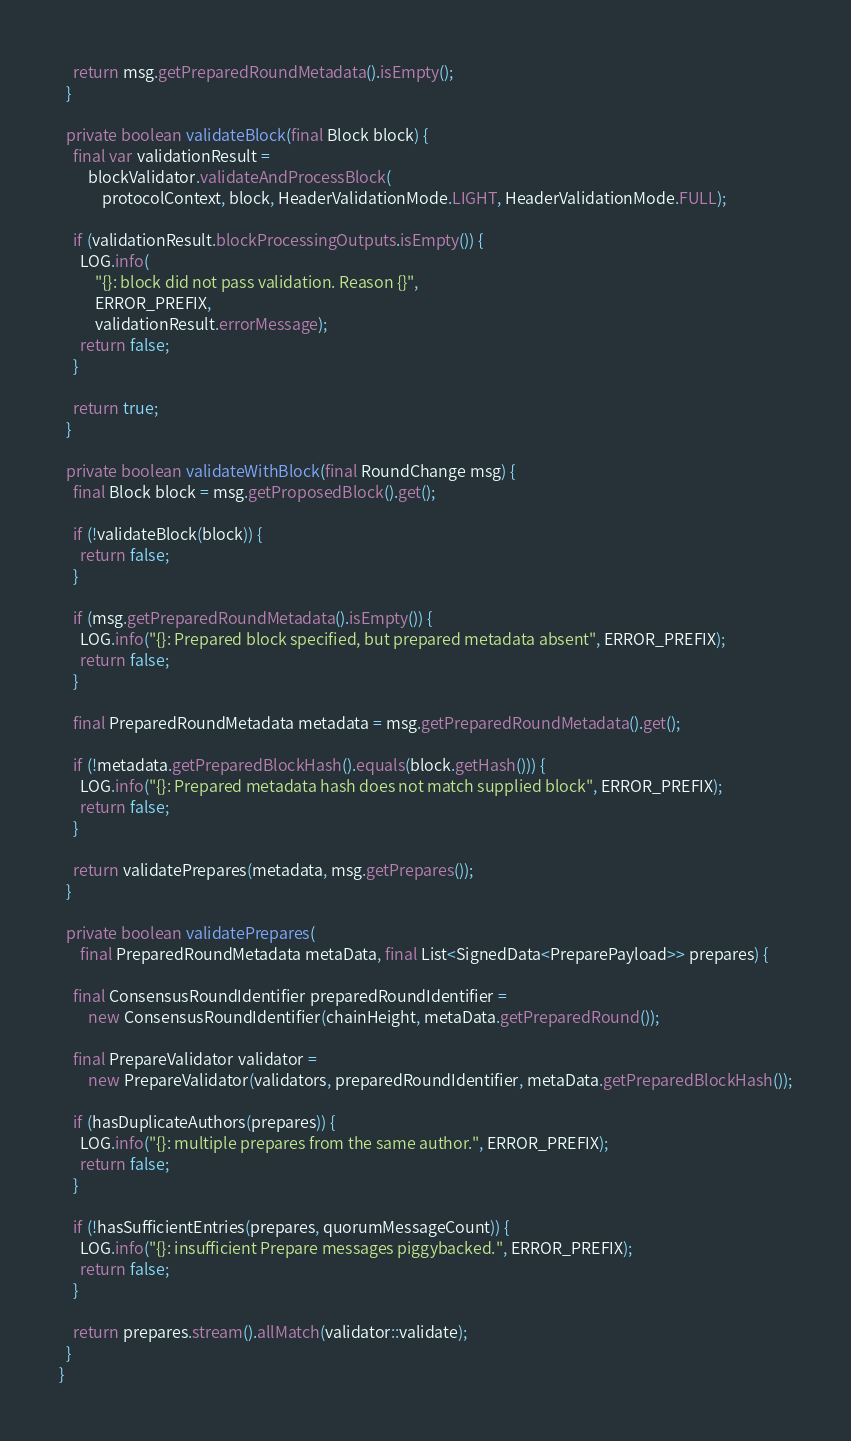Convert code to text. <code><loc_0><loc_0><loc_500><loc_500><_Java_>
    return msg.getPreparedRoundMetadata().isEmpty();
  }

  private boolean validateBlock(final Block block) {
    final var validationResult =
        blockValidator.validateAndProcessBlock(
            protocolContext, block, HeaderValidationMode.LIGHT, HeaderValidationMode.FULL);

    if (validationResult.blockProcessingOutputs.isEmpty()) {
      LOG.info(
          "{}: block did not pass validation. Reason {}",
          ERROR_PREFIX,
          validationResult.errorMessage);
      return false;
    }

    return true;
  }

  private boolean validateWithBlock(final RoundChange msg) {
    final Block block = msg.getProposedBlock().get();

    if (!validateBlock(block)) {
      return false;
    }

    if (msg.getPreparedRoundMetadata().isEmpty()) {
      LOG.info("{}: Prepared block specified, but prepared metadata absent", ERROR_PREFIX);
      return false;
    }

    final PreparedRoundMetadata metadata = msg.getPreparedRoundMetadata().get();

    if (!metadata.getPreparedBlockHash().equals(block.getHash())) {
      LOG.info("{}: Prepared metadata hash does not match supplied block", ERROR_PREFIX);
      return false;
    }

    return validatePrepares(metadata, msg.getPrepares());
  }

  private boolean validatePrepares(
      final PreparedRoundMetadata metaData, final List<SignedData<PreparePayload>> prepares) {

    final ConsensusRoundIdentifier preparedRoundIdentifier =
        new ConsensusRoundIdentifier(chainHeight, metaData.getPreparedRound());

    final PrepareValidator validator =
        new PrepareValidator(validators, preparedRoundIdentifier, metaData.getPreparedBlockHash());

    if (hasDuplicateAuthors(prepares)) {
      LOG.info("{}: multiple prepares from the same author.", ERROR_PREFIX);
      return false;
    }

    if (!hasSufficientEntries(prepares, quorumMessageCount)) {
      LOG.info("{}: insufficient Prepare messages piggybacked.", ERROR_PREFIX);
      return false;
    }

    return prepares.stream().allMatch(validator::validate);
  }
}
</code> 